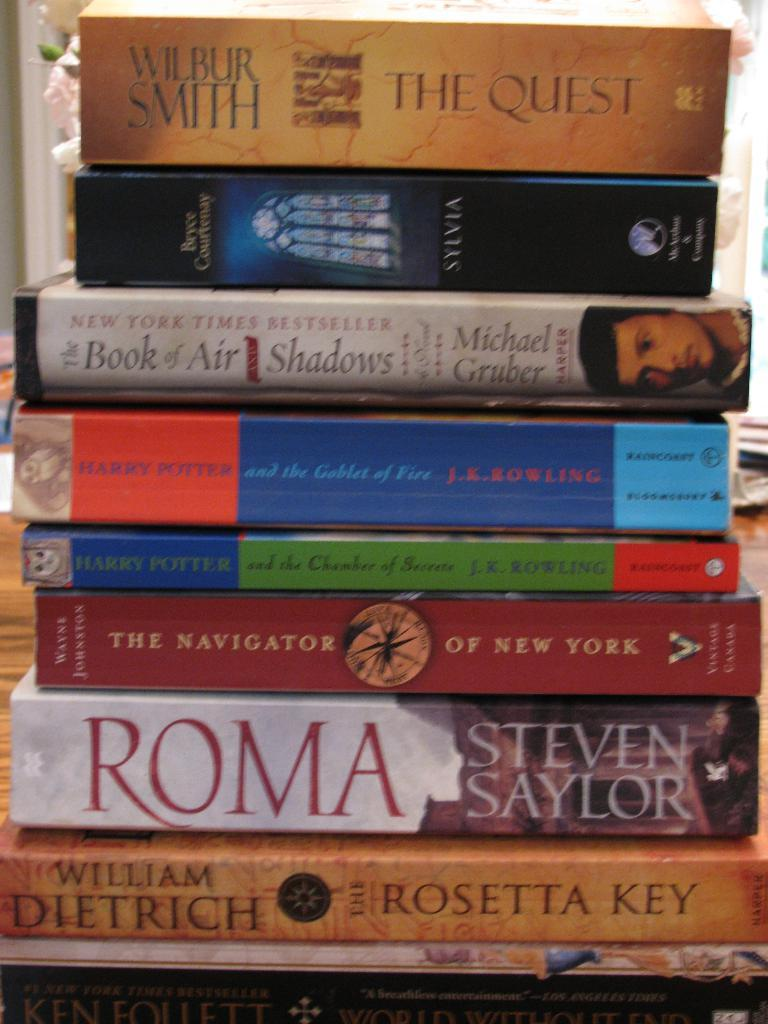<image>
Present a compact description of the photo's key features. A stack of books that has 'The Quest' at the top of it. 